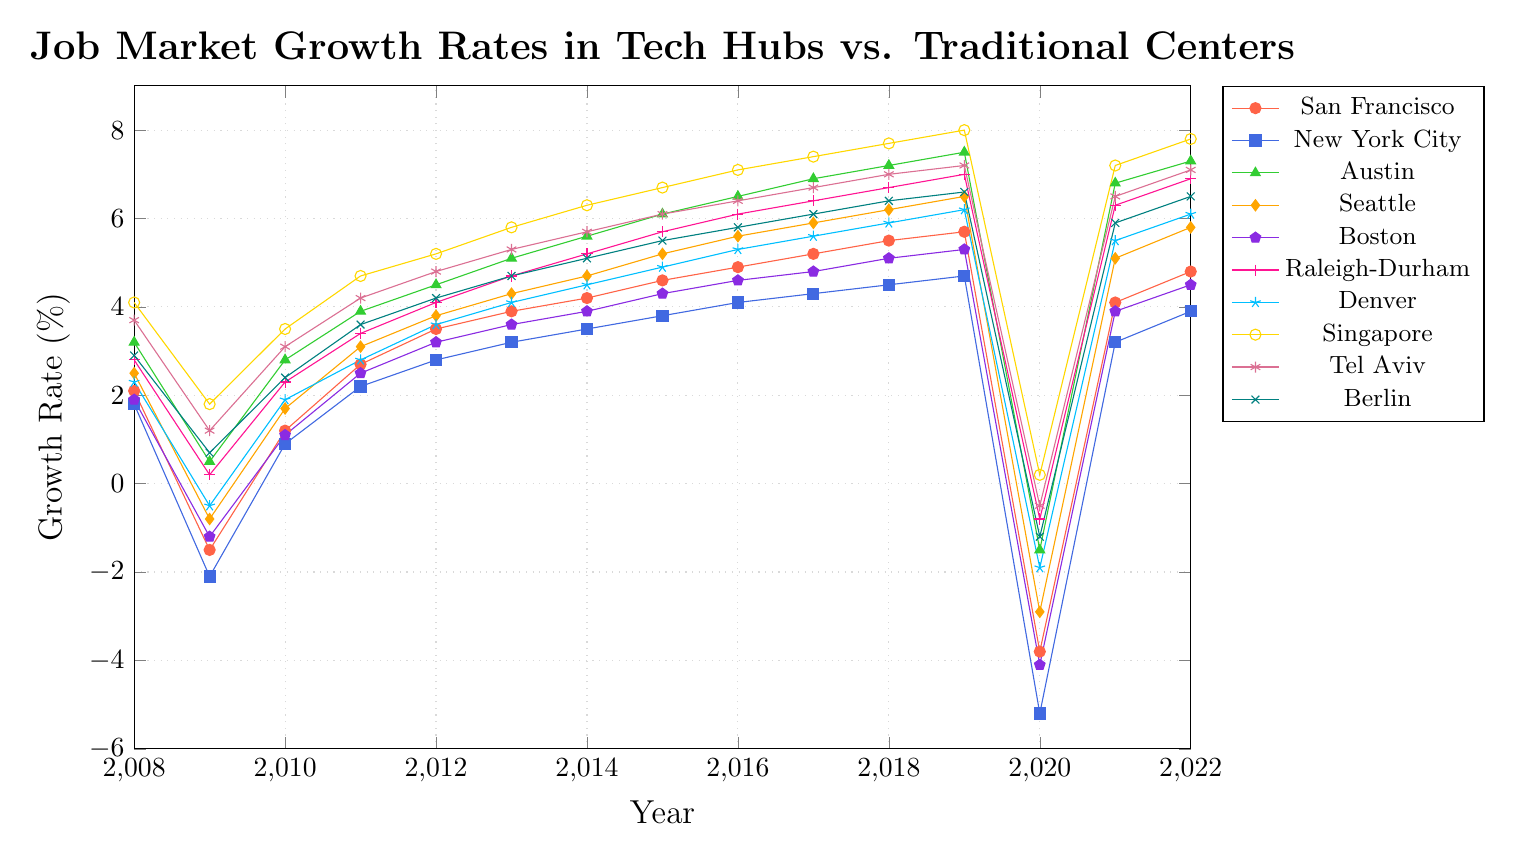Which city had the highest job market growth rate in 2019? The highest job market growth rate in 2019 among all the cities is represented visually by the tallest point on the line chart for that year. By examining the plot, Singapore appears to have the highest growth rate in 2019.
Answer: Singapore Between 2008 and 2022, which city showed the most significant drop in growth rate, and in which year did this occur? To determine the most significant drop, we need to look at the steepest negative slope in any city's growth rate over the years. The most noticeable drop is seen in New York City in 2020, where the growth rate dropped from 4.7% in 2019 to -5.2% in 2020.
Answer: New York City, 2020 What was the average growth rate for Austin from 2015 to 2019? To find the average, sum the growth rates for Austin for each year between 2015 and 2019 and divide by the number of years. The values are 6.1, 6.5, 6.9, 7.2, and 7.5. Sum these values: 6.1 + 6.5 + 6.9 + 7.2 + 7.5 = 34.2. Divide by 5: 34.2 / 5 = 6.84.
Answer: 6.84 Which cities showed growth rates above 5% in 2017? Identify the points above the 5% mark on the y-axis for the year 2017. The cities represented by these points are Austin (6.9%), Seattle (5.9%), Raleigh-Durham (6.4%), Denver (5.6%), Singapore (7.4%), Tel Aviv (6.7%), and Berlin (6.1%).
Answer: Austin, Seattle, Raleigh-Durham, Denver, Singapore, Tel Aviv, Berlin Compare the growth rate trends in San Francisco and New York City. Which city had more years with a positive growth rate? Count the number of years where the growth rate is above 0% for each city. For San Francisco: 2008, 2010-2019, 2021, and 2022 (13 years). For New York City: 2008, 2010-2019, 2021, and 2022 (13 years). Both cities have the same number of years with positive growth rates.
Answer: Both cities had 13 years with positive growth rates Which city experienced the least impact during the 2020 economic downturn? Determine the city with the smallest decrease in growth rate from 2019 to 2020. Singapore shows the least impact with a change from 8.0% in 2019 to 0.2% in 2020, which is a reduction of 7.8 percentage points.
Answer: Singapore How did the growth rate of Berlin change from 2008 to 2022? Observe the initial and final points for Berlin. In 2008, Berlin had a growth rate of 2.9%, and by 2022, it had increased to 6.5%. The overall change is 6.5% - 2.9% = 3.6%.
Answer: Increased by 3.6% What is the difference in growth rates between Seattle and Boston in 2014? Identify the growth rates for Seattle (4.7%) and Boston (3.9%) in 2014. Calculate the difference: 4.7% - 3.9% = 0.8%.
Answer: 0.8% How many cities had a negative growth rate in 2009? Count the cities that have values below 0% for the year 2009. The cities are San Francisco (-1.5%), New York City (-2.1%), Seattle (-0.8%), Boston (-1.2%), Denver (-0.5%), and Tel Aviv (1.2%).
Answer: 5 